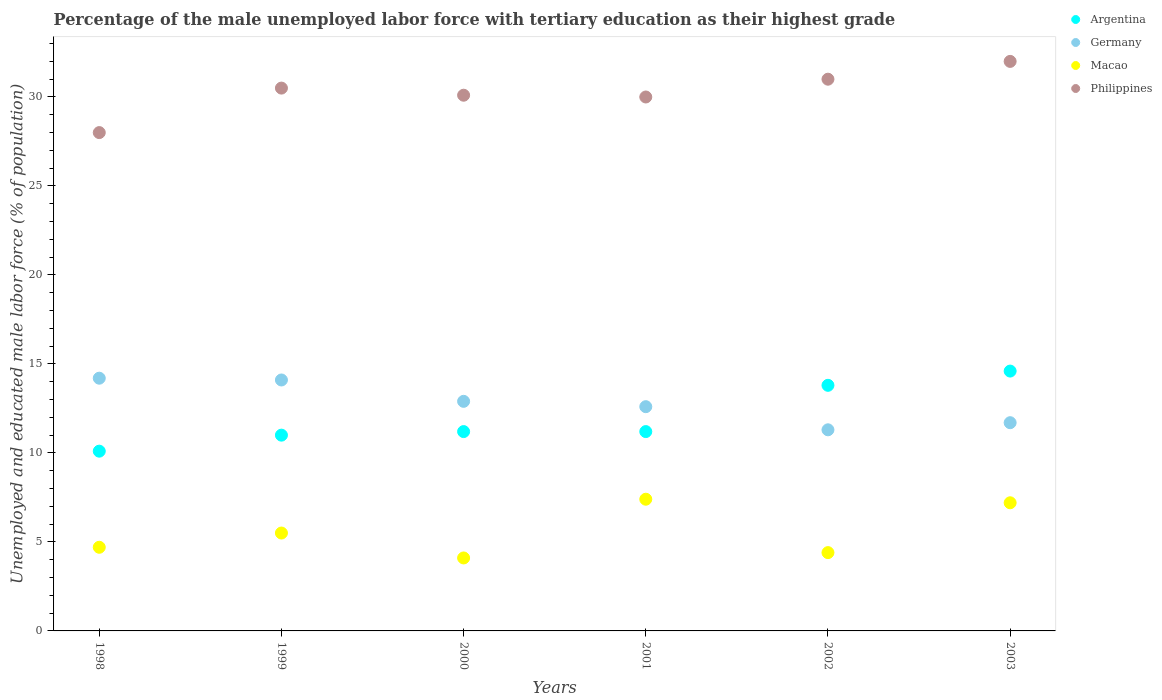How many different coloured dotlines are there?
Provide a succinct answer. 4. Is the number of dotlines equal to the number of legend labels?
Give a very brief answer. Yes. What is the percentage of the unemployed male labor force with tertiary education in Argentina in 2003?
Offer a terse response. 14.6. Across all years, what is the maximum percentage of the unemployed male labor force with tertiary education in Philippines?
Give a very brief answer. 32. Across all years, what is the minimum percentage of the unemployed male labor force with tertiary education in Germany?
Provide a short and direct response. 11.3. What is the total percentage of the unemployed male labor force with tertiary education in Argentina in the graph?
Offer a very short reply. 71.9. What is the difference between the percentage of the unemployed male labor force with tertiary education in Argentina in 2001 and that in 2003?
Your answer should be very brief. -3.4. What is the difference between the percentage of the unemployed male labor force with tertiary education in Macao in 2002 and the percentage of the unemployed male labor force with tertiary education in Argentina in 2000?
Provide a short and direct response. -6.8. What is the average percentage of the unemployed male labor force with tertiary education in Philippines per year?
Offer a terse response. 30.27. In the year 1998, what is the difference between the percentage of the unemployed male labor force with tertiary education in Philippines and percentage of the unemployed male labor force with tertiary education in Macao?
Your answer should be very brief. 23.3. What is the ratio of the percentage of the unemployed male labor force with tertiary education in Macao in 2000 to that in 2001?
Offer a very short reply. 0.55. What is the difference between the highest and the second highest percentage of the unemployed male labor force with tertiary education in Argentina?
Your response must be concise. 0.8. What is the difference between the highest and the lowest percentage of the unemployed male labor force with tertiary education in Philippines?
Provide a short and direct response. 4. Is it the case that in every year, the sum of the percentage of the unemployed male labor force with tertiary education in Macao and percentage of the unemployed male labor force with tertiary education in Germany  is greater than the percentage of the unemployed male labor force with tertiary education in Philippines?
Keep it short and to the point. No. Does the percentage of the unemployed male labor force with tertiary education in Argentina monotonically increase over the years?
Offer a very short reply. No. Where does the legend appear in the graph?
Your answer should be very brief. Top right. How many legend labels are there?
Your answer should be very brief. 4. How are the legend labels stacked?
Make the answer very short. Vertical. What is the title of the graph?
Ensure brevity in your answer.  Percentage of the male unemployed labor force with tertiary education as their highest grade. Does "Russian Federation" appear as one of the legend labels in the graph?
Provide a short and direct response. No. What is the label or title of the X-axis?
Ensure brevity in your answer.  Years. What is the label or title of the Y-axis?
Make the answer very short. Unemployed and educated male labor force (% of population). What is the Unemployed and educated male labor force (% of population) in Argentina in 1998?
Make the answer very short. 10.1. What is the Unemployed and educated male labor force (% of population) of Germany in 1998?
Keep it short and to the point. 14.2. What is the Unemployed and educated male labor force (% of population) in Macao in 1998?
Your answer should be compact. 4.7. What is the Unemployed and educated male labor force (% of population) of Argentina in 1999?
Your response must be concise. 11. What is the Unemployed and educated male labor force (% of population) of Germany in 1999?
Your response must be concise. 14.1. What is the Unemployed and educated male labor force (% of population) of Philippines in 1999?
Keep it short and to the point. 30.5. What is the Unemployed and educated male labor force (% of population) in Argentina in 2000?
Keep it short and to the point. 11.2. What is the Unemployed and educated male labor force (% of population) in Germany in 2000?
Make the answer very short. 12.9. What is the Unemployed and educated male labor force (% of population) in Macao in 2000?
Offer a terse response. 4.1. What is the Unemployed and educated male labor force (% of population) in Philippines in 2000?
Your answer should be compact. 30.1. What is the Unemployed and educated male labor force (% of population) of Argentina in 2001?
Provide a short and direct response. 11.2. What is the Unemployed and educated male labor force (% of population) of Germany in 2001?
Offer a terse response. 12.6. What is the Unemployed and educated male labor force (% of population) of Macao in 2001?
Your answer should be very brief. 7.4. What is the Unemployed and educated male labor force (% of population) of Philippines in 2001?
Your answer should be compact. 30. What is the Unemployed and educated male labor force (% of population) in Argentina in 2002?
Offer a terse response. 13.8. What is the Unemployed and educated male labor force (% of population) in Germany in 2002?
Provide a succinct answer. 11.3. What is the Unemployed and educated male labor force (% of population) in Macao in 2002?
Make the answer very short. 4.4. What is the Unemployed and educated male labor force (% of population) of Argentina in 2003?
Your response must be concise. 14.6. What is the Unemployed and educated male labor force (% of population) of Germany in 2003?
Offer a terse response. 11.7. What is the Unemployed and educated male labor force (% of population) of Macao in 2003?
Give a very brief answer. 7.2. What is the Unemployed and educated male labor force (% of population) in Philippines in 2003?
Provide a short and direct response. 32. Across all years, what is the maximum Unemployed and educated male labor force (% of population) in Argentina?
Offer a very short reply. 14.6. Across all years, what is the maximum Unemployed and educated male labor force (% of population) in Germany?
Ensure brevity in your answer.  14.2. Across all years, what is the maximum Unemployed and educated male labor force (% of population) of Macao?
Make the answer very short. 7.4. Across all years, what is the maximum Unemployed and educated male labor force (% of population) in Philippines?
Keep it short and to the point. 32. Across all years, what is the minimum Unemployed and educated male labor force (% of population) in Argentina?
Your response must be concise. 10.1. Across all years, what is the minimum Unemployed and educated male labor force (% of population) of Germany?
Make the answer very short. 11.3. Across all years, what is the minimum Unemployed and educated male labor force (% of population) in Macao?
Your response must be concise. 4.1. What is the total Unemployed and educated male labor force (% of population) in Argentina in the graph?
Your response must be concise. 71.9. What is the total Unemployed and educated male labor force (% of population) in Germany in the graph?
Your response must be concise. 76.8. What is the total Unemployed and educated male labor force (% of population) in Macao in the graph?
Keep it short and to the point. 33.3. What is the total Unemployed and educated male labor force (% of population) of Philippines in the graph?
Provide a short and direct response. 181.6. What is the difference between the Unemployed and educated male labor force (% of population) in Germany in 1998 and that in 1999?
Your response must be concise. 0.1. What is the difference between the Unemployed and educated male labor force (% of population) in Macao in 1998 and that in 1999?
Make the answer very short. -0.8. What is the difference between the Unemployed and educated male labor force (% of population) of Macao in 1998 and that in 2000?
Your answer should be compact. 0.6. What is the difference between the Unemployed and educated male labor force (% of population) of Argentina in 1998 and that in 2001?
Provide a succinct answer. -1.1. What is the difference between the Unemployed and educated male labor force (% of population) of Macao in 1998 and that in 2001?
Your answer should be very brief. -2.7. What is the difference between the Unemployed and educated male labor force (% of population) of Philippines in 1998 and that in 2002?
Your response must be concise. -3. What is the difference between the Unemployed and educated male labor force (% of population) in Argentina in 1998 and that in 2003?
Your answer should be very brief. -4.5. What is the difference between the Unemployed and educated male labor force (% of population) in Philippines in 1998 and that in 2003?
Provide a short and direct response. -4. What is the difference between the Unemployed and educated male labor force (% of population) of Philippines in 1999 and that in 2000?
Your response must be concise. 0.4. What is the difference between the Unemployed and educated male labor force (% of population) in Germany in 1999 and that in 2001?
Ensure brevity in your answer.  1.5. What is the difference between the Unemployed and educated male labor force (% of population) of Macao in 1999 and that in 2001?
Ensure brevity in your answer.  -1.9. What is the difference between the Unemployed and educated male labor force (% of population) of Philippines in 1999 and that in 2001?
Your response must be concise. 0.5. What is the difference between the Unemployed and educated male labor force (% of population) in Argentina in 1999 and that in 2002?
Provide a succinct answer. -2.8. What is the difference between the Unemployed and educated male labor force (% of population) in Macao in 1999 and that in 2002?
Give a very brief answer. 1.1. What is the difference between the Unemployed and educated male labor force (% of population) in Philippines in 1999 and that in 2002?
Your response must be concise. -0.5. What is the difference between the Unemployed and educated male labor force (% of population) of Germany in 1999 and that in 2003?
Keep it short and to the point. 2.4. What is the difference between the Unemployed and educated male labor force (% of population) in Macao in 2000 and that in 2001?
Provide a succinct answer. -3.3. What is the difference between the Unemployed and educated male labor force (% of population) of Germany in 2000 and that in 2002?
Your answer should be compact. 1.6. What is the difference between the Unemployed and educated male labor force (% of population) in Macao in 2000 and that in 2002?
Offer a very short reply. -0.3. What is the difference between the Unemployed and educated male labor force (% of population) of Germany in 2000 and that in 2003?
Give a very brief answer. 1.2. What is the difference between the Unemployed and educated male labor force (% of population) of Philippines in 2000 and that in 2003?
Make the answer very short. -1.9. What is the difference between the Unemployed and educated male labor force (% of population) of Macao in 2001 and that in 2002?
Offer a very short reply. 3. What is the difference between the Unemployed and educated male labor force (% of population) in Argentina in 2001 and that in 2003?
Make the answer very short. -3.4. What is the difference between the Unemployed and educated male labor force (% of population) of Germany in 2001 and that in 2003?
Your response must be concise. 0.9. What is the difference between the Unemployed and educated male labor force (% of population) in Macao in 2001 and that in 2003?
Your answer should be compact. 0.2. What is the difference between the Unemployed and educated male labor force (% of population) in Argentina in 2002 and that in 2003?
Make the answer very short. -0.8. What is the difference between the Unemployed and educated male labor force (% of population) of Germany in 2002 and that in 2003?
Offer a very short reply. -0.4. What is the difference between the Unemployed and educated male labor force (% of population) of Macao in 2002 and that in 2003?
Provide a succinct answer. -2.8. What is the difference between the Unemployed and educated male labor force (% of population) of Argentina in 1998 and the Unemployed and educated male labor force (% of population) of Philippines in 1999?
Ensure brevity in your answer.  -20.4. What is the difference between the Unemployed and educated male labor force (% of population) in Germany in 1998 and the Unemployed and educated male labor force (% of population) in Macao in 1999?
Give a very brief answer. 8.7. What is the difference between the Unemployed and educated male labor force (% of population) in Germany in 1998 and the Unemployed and educated male labor force (% of population) in Philippines in 1999?
Ensure brevity in your answer.  -16.3. What is the difference between the Unemployed and educated male labor force (% of population) of Macao in 1998 and the Unemployed and educated male labor force (% of population) of Philippines in 1999?
Your response must be concise. -25.8. What is the difference between the Unemployed and educated male labor force (% of population) of Argentina in 1998 and the Unemployed and educated male labor force (% of population) of Germany in 2000?
Your answer should be compact. -2.8. What is the difference between the Unemployed and educated male labor force (% of population) of Argentina in 1998 and the Unemployed and educated male labor force (% of population) of Macao in 2000?
Your response must be concise. 6. What is the difference between the Unemployed and educated male labor force (% of population) of Argentina in 1998 and the Unemployed and educated male labor force (% of population) of Philippines in 2000?
Provide a short and direct response. -20. What is the difference between the Unemployed and educated male labor force (% of population) in Germany in 1998 and the Unemployed and educated male labor force (% of population) in Philippines in 2000?
Provide a short and direct response. -15.9. What is the difference between the Unemployed and educated male labor force (% of population) in Macao in 1998 and the Unemployed and educated male labor force (% of population) in Philippines in 2000?
Your response must be concise. -25.4. What is the difference between the Unemployed and educated male labor force (% of population) of Argentina in 1998 and the Unemployed and educated male labor force (% of population) of Macao in 2001?
Provide a short and direct response. 2.7. What is the difference between the Unemployed and educated male labor force (% of population) of Argentina in 1998 and the Unemployed and educated male labor force (% of population) of Philippines in 2001?
Make the answer very short. -19.9. What is the difference between the Unemployed and educated male labor force (% of population) in Germany in 1998 and the Unemployed and educated male labor force (% of population) in Philippines in 2001?
Provide a short and direct response. -15.8. What is the difference between the Unemployed and educated male labor force (% of population) in Macao in 1998 and the Unemployed and educated male labor force (% of population) in Philippines in 2001?
Offer a very short reply. -25.3. What is the difference between the Unemployed and educated male labor force (% of population) in Argentina in 1998 and the Unemployed and educated male labor force (% of population) in Germany in 2002?
Keep it short and to the point. -1.2. What is the difference between the Unemployed and educated male labor force (% of population) in Argentina in 1998 and the Unemployed and educated male labor force (% of population) in Philippines in 2002?
Offer a terse response. -20.9. What is the difference between the Unemployed and educated male labor force (% of population) in Germany in 1998 and the Unemployed and educated male labor force (% of population) in Philippines in 2002?
Your answer should be compact. -16.8. What is the difference between the Unemployed and educated male labor force (% of population) of Macao in 1998 and the Unemployed and educated male labor force (% of population) of Philippines in 2002?
Keep it short and to the point. -26.3. What is the difference between the Unemployed and educated male labor force (% of population) of Argentina in 1998 and the Unemployed and educated male labor force (% of population) of Germany in 2003?
Offer a very short reply. -1.6. What is the difference between the Unemployed and educated male labor force (% of population) of Argentina in 1998 and the Unemployed and educated male labor force (% of population) of Macao in 2003?
Provide a succinct answer. 2.9. What is the difference between the Unemployed and educated male labor force (% of population) of Argentina in 1998 and the Unemployed and educated male labor force (% of population) of Philippines in 2003?
Your response must be concise. -21.9. What is the difference between the Unemployed and educated male labor force (% of population) in Germany in 1998 and the Unemployed and educated male labor force (% of population) in Macao in 2003?
Provide a short and direct response. 7. What is the difference between the Unemployed and educated male labor force (% of population) in Germany in 1998 and the Unemployed and educated male labor force (% of population) in Philippines in 2003?
Your answer should be very brief. -17.8. What is the difference between the Unemployed and educated male labor force (% of population) in Macao in 1998 and the Unemployed and educated male labor force (% of population) in Philippines in 2003?
Make the answer very short. -27.3. What is the difference between the Unemployed and educated male labor force (% of population) of Argentina in 1999 and the Unemployed and educated male labor force (% of population) of Germany in 2000?
Your response must be concise. -1.9. What is the difference between the Unemployed and educated male labor force (% of population) of Argentina in 1999 and the Unemployed and educated male labor force (% of population) of Macao in 2000?
Make the answer very short. 6.9. What is the difference between the Unemployed and educated male labor force (% of population) in Argentina in 1999 and the Unemployed and educated male labor force (% of population) in Philippines in 2000?
Offer a very short reply. -19.1. What is the difference between the Unemployed and educated male labor force (% of population) of Germany in 1999 and the Unemployed and educated male labor force (% of population) of Macao in 2000?
Your response must be concise. 10. What is the difference between the Unemployed and educated male labor force (% of population) in Germany in 1999 and the Unemployed and educated male labor force (% of population) in Philippines in 2000?
Your answer should be compact. -16. What is the difference between the Unemployed and educated male labor force (% of population) in Macao in 1999 and the Unemployed and educated male labor force (% of population) in Philippines in 2000?
Keep it short and to the point. -24.6. What is the difference between the Unemployed and educated male labor force (% of population) of Argentina in 1999 and the Unemployed and educated male labor force (% of population) of Philippines in 2001?
Provide a short and direct response. -19. What is the difference between the Unemployed and educated male labor force (% of population) in Germany in 1999 and the Unemployed and educated male labor force (% of population) in Philippines in 2001?
Provide a short and direct response. -15.9. What is the difference between the Unemployed and educated male labor force (% of population) of Macao in 1999 and the Unemployed and educated male labor force (% of population) of Philippines in 2001?
Keep it short and to the point. -24.5. What is the difference between the Unemployed and educated male labor force (% of population) in Argentina in 1999 and the Unemployed and educated male labor force (% of population) in Macao in 2002?
Your answer should be very brief. 6.6. What is the difference between the Unemployed and educated male labor force (% of population) in Argentina in 1999 and the Unemployed and educated male labor force (% of population) in Philippines in 2002?
Offer a very short reply. -20. What is the difference between the Unemployed and educated male labor force (% of population) in Germany in 1999 and the Unemployed and educated male labor force (% of population) in Macao in 2002?
Give a very brief answer. 9.7. What is the difference between the Unemployed and educated male labor force (% of population) of Germany in 1999 and the Unemployed and educated male labor force (% of population) of Philippines in 2002?
Your answer should be very brief. -16.9. What is the difference between the Unemployed and educated male labor force (% of population) in Macao in 1999 and the Unemployed and educated male labor force (% of population) in Philippines in 2002?
Keep it short and to the point. -25.5. What is the difference between the Unemployed and educated male labor force (% of population) in Argentina in 1999 and the Unemployed and educated male labor force (% of population) in Germany in 2003?
Your answer should be compact. -0.7. What is the difference between the Unemployed and educated male labor force (% of population) of Argentina in 1999 and the Unemployed and educated male labor force (% of population) of Macao in 2003?
Your answer should be very brief. 3.8. What is the difference between the Unemployed and educated male labor force (% of population) in Argentina in 1999 and the Unemployed and educated male labor force (% of population) in Philippines in 2003?
Keep it short and to the point. -21. What is the difference between the Unemployed and educated male labor force (% of population) of Germany in 1999 and the Unemployed and educated male labor force (% of population) of Philippines in 2003?
Give a very brief answer. -17.9. What is the difference between the Unemployed and educated male labor force (% of population) of Macao in 1999 and the Unemployed and educated male labor force (% of population) of Philippines in 2003?
Offer a terse response. -26.5. What is the difference between the Unemployed and educated male labor force (% of population) in Argentina in 2000 and the Unemployed and educated male labor force (% of population) in Germany in 2001?
Offer a very short reply. -1.4. What is the difference between the Unemployed and educated male labor force (% of population) of Argentina in 2000 and the Unemployed and educated male labor force (% of population) of Macao in 2001?
Offer a terse response. 3.8. What is the difference between the Unemployed and educated male labor force (% of population) of Argentina in 2000 and the Unemployed and educated male labor force (% of population) of Philippines in 2001?
Make the answer very short. -18.8. What is the difference between the Unemployed and educated male labor force (% of population) of Germany in 2000 and the Unemployed and educated male labor force (% of population) of Philippines in 2001?
Your answer should be very brief. -17.1. What is the difference between the Unemployed and educated male labor force (% of population) of Macao in 2000 and the Unemployed and educated male labor force (% of population) of Philippines in 2001?
Keep it short and to the point. -25.9. What is the difference between the Unemployed and educated male labor force (% of population) in Argentina in 2000 and the Unemployed and educated male labor force (% of population) in Germany in 2002?
Offer a terse response. -0.1. What is the difference between the Unemployed and educated male labor force (% of population) of Argentina in 2000 and the Unemployed and educated male labor force (% of population) of Macao in 2002?
Your answer should be very brief. 6.8. What is the difference between the Unemployed and educated male labor force (% of population) in Argentina in 2000 and the Unemployed and educated male labor force (% of population) in Philippines in 2002?
Keep it short and to the point. -19.8. What is the difference between the Unemployed and educated male labor force (% of population) of Germany in 2000 and the Unemployed and educated male labor force (% of population) of Macao in 2002?
Keep it short and to the point. 8.5. What is the difference between the Unemployed and educated male labor force (% of population) of Germany in 2000 and the Unemployed and educated male labor force (% of population) of Philippines in 2002?
Your response must be concise. -18.1. What is the difference between the Unemployed and educated male labor force (% of population) in Macao in 2000 and the Unemployed and educated male labor force (% of population) in Philippines in 2002?
Provide a succinct answer. -26.9. What is the difference between the Unemployed and educated male labor force (% of population) in Argentina in 2000 and the Unemployed and educated male labor force (% of population) in Philippines in 2003?
Keep it short and to the point. -20.8. What is the difference between the Unemployed and educated male labor force (% of population) of Germany in 2000 and the Unemployed and educated male labor force (% of population) of Philippines in 2003?
Your answer should be compact. -19.1. What is the difference between the Unemployed and educated male labor force (% of population) in Macao in 2000 and the Unemployed and educated male labor force (% of population) in Philippines in 2003?
Offer a very short reply. -27.9. What is the difference between the Unemployed and educated male labor force (% of population) in Argentina in 2001 and the Unemployed and educated male labor force (% of population) in Germany in 2002?
Provide a short and direct response. -0.1. What is the difference between the Unemployed and educated male labor force (% of population) of Argentina in 2001 and the Unemployed and educated male labor force (% of population) of Macao in 2002?
Offer a very short reply. 6.8. What is the difference between the Unemployed and educated male labor force (% of population) of Argentina in 2001 and the Unemployed and educated male labor force (% of population) of Philippines in 2002?
Your response must be concise. -19.8. What is the difference between the Unemployed and educated male labor force (% of population) of Germany in 2001 and the Unemployed and educated male labor force (% of population) of Macao in 2002?
Give a very brief answer. 8.2. What is the difference between the Unemployed and educated male labor force (% of population) of Germany in 2001 and the Unemployed and educated male labor force (% of population) of Philippines in 2002?
Your answer should be compact. -18.4. What is the difference between the Unemployed and educated male labor force (% of population) in Macao in 2001 and the Unemployed and educated male labor force (% of population) in Philippines in 2002?
Provide a succinct answer. -23.6. What is the difference between the Unemployed and educated male labor force (% of population) in Argentina in 2001 and the Unemployed and educated male labor force (% of population) in Macao in 2003?
Ensure brevity in your answer.  4. What is the difference between the Unemployed and educated male labor force (% of population) of Argentina in 2001 and the Unemployed and educated male labor force (% of population) of Philippines in 2003?
Your answer should be compact. -20.8. What is the difference between the Unemployed and educated male labor force (% of population) of Germany in 2001 and the Unemployed and educated male labor force (% of population) of Philippines in 2003?
Your answer should be very brief. -19.4. What is the difference between the Unemployed and educated male labor force (% of population) of Macao in 2001 and the Unemployed and educated male labor force (% of population) of Philippines in 2003?
Your response must be concise. -24.6. What is the difference between the Unemployed and educated male labor force (% of population) of Argentina in 2002 and the Unemployed and educated male labor force (% of population) of Germany in 2003?
Provide a short and direct response. 2.1. What is the difference between the Unemployed and educated male labor force (% of population) of Argentina in 2002 and the Unemployed and educated male labor force (% of population) of Macao in 2003?
Offer a terse response. 6.6. What is the difference between the Unemployed and educated male labor force (% of population) of Argentina in 2002 and the Unemployed and educated male labor force (% of population) of Philippines in 2003?
Keep it short and to the point. -18.2. What is the difference between the Unemployed and educated male labor force (% of population) of Germany in 2002 and the Unemployed and educated male labor force (% of population) of Philippines in 2003?
Make the answer very short. -20.7. What is the difference between the Unemployed and educated male labor force (% of population) of Macao in 2002 and the Unemployed and educated male labor force (% of population) of Philippines in 2003?
Make the answer very short. -27.6. What is the average Unemployed and educated male labor force (% of population) of Argentina per year?
Give a very brief answer. 11.98. What is the average Unemployed and educated male labor force (% of population) in Germany per year?
Your answer should be very brief. 12.8. What is the average Unemployed and educated male labor force (% of population) of Macao per year?
Keep it short and to the point. 5.55. What is the average Unemployed and educated male labor force (% of population) of Philippines per year?
Your answer should be compact. 30.27. In the year 1998, what is the difference between the Unemployed and educated male labor force (% of population) of Argentina and Unemployed and educated male labor force (% of population) of Germany?
Keep it short and to the point. -4.1. In the year 1998, what is the difference between the Unemployed and educated male labor force (% of population) in Argentina and Unemployed and educated male labor force (% of population) in Macao?
Offer a very short reply. 5.4. In the year 1998, what is the difference between the Unemployed and educated male labor force (% of population) in Argentina and Unemployed and educated male labor force (% of population) in Philippines?
Offer a very short reply. -17.9. In the year 1998, what is the difference between the Unemployed and educated male labor force (% of population) of Macao and Unemployed and educated male labor force (% of population) of Philippines?
Provide a succinct answer. -23.3. In the year 1999, what is the difference between the Unemployed and educated male labor force (% of population) in Argentina and Unemployed and educated male labor force (% of population) in Philippines?
Your answer should be very brief. -19.5. In the year 1999, what is the difference between the Unemployed and educated male labor force (% of population) in Germany and Unemployed and educated male labor force (% of population) in Macao?
Provide a short and direct response. 8.6. In the year 1999, what is the difference between the Unemployed and educated male labor force (% of population) in Germany and Unemployed and educated male labor force (% of population) in Philippines?
Offer a terse response. -16.4. In the year 1999, what is the difference between the Unemployed and educated male labor force (% of population) in Macao and Unemployed and educated male labor force (% of population) in Philippines?
Your response must be concise. -25. In the year 2000, what is the difference between the Unemployed and educated male labor force (% of population) in Argentina and Unemployed and educated male labor force (% of population) in Germany?
Your answer should be compact. -1.7. In the year 2000, what is the difference between the Unemployed and educated male labor force (% of population) of Argentina and Unemployed and educated male labor force (% of population) of Macao?
Your answer should be very brief. 7.1. In the year 2000, what is the difference between the Unemployed and educated male labor force (% of population) of Argentina and Unemployed and educated male labor force (% of population) of Philippines?
Keep it short and to the point. -18.9. In the year 2000, what is the difference between the Unemployed and educated male labor force (% of population) of Germany and Unemployed and educated male labor force (% of population) of Macao?
Provide a succinct answer. 8.8. In the year 2000, what is the difference between the Unemployed and educated male labor force (% of population) in Germany and Unemployed and educated male labor force (% of population) in Philippines?
Give a very brief answer. -17.2. In the year 2001, what is the difference between the Unemployed and educated male labor force (% of population) of Argentina and Unemployed and educated male labor force (% of population) of Philippines?
Your response must be concise. -18.8. In the year 2001, what is the difference between the Unemployed and educated male labor force (% of population) in Germany and Unemployed and educated male labor force (% of population) in Philippines?
Give a very brief answer. -17.4. In the year 2001, what is the difference between the Unemployed and educated male labor force (% of population) in Macao and Unemployed and educated male labor force (% of population) in Philippines?
Provide a short and direct response. -22.6. In the year 2002, what is the difference between the Unemployed and educated male labor force (% of population) of Argentina and Unemployed and educated male labor force (% of population) of Philippines?
Make the answer very short. -17.2. In the year 2002, what is the difference between the Unemployed and educated male labor force (% of population) in Germany and Unemployed and educated male labor force (% of population) in Philippines?
Provide a short and direct response. -19.7. In the year 2002, what is the difference between the Unemployed and educated male labor force (% of population) in Macao and Unemployed and educated male labor force (% of population) in Philippines?
Your response must be concise. -26.6. In the year 2003, what is the difference between the Unemployed and educated male labor force (% of population) in Argentina and Unemployed and educated male labor force (% of population) in Germany?
Your answer should be compact. 2.9. In the year 2003, what is the difference between the Unemployed and educated male labor force (% of population) of Argentina and Unemployed and educated male labor force (% of population) of Philippines?
Your answer should be very brief. -17.4. In the year 2003, what is the difference between the Unemployed and educated male labor force (% of population) in Germany and Unemployed and educated male labor force (% of population) in Macao?
Your answer should be very brief. 4.5. In the year 2003, what is the difference between the Unemployed and educated male labor force (% of population) in Germany and Unemployed and educated male labor force (% of population) in Philippines?
Ensure brevity in your answer.  -20.3. In the year 2003, what is the difference between the Unemployed and educated male labor force (% of population) in Macao and Unemployed and educated male labor force (% of population) in Philippines?
Keep it short and to the point. -24.8. What is the ratio of the Unemployed and educated male labor force (% of population) of Argentina in 1998 to that in 1999?
Offer a very short reply. 0.92. What is the ratio of the Unemployed and educated male labor force (% of population) of Germany in 1998 to that in 1999?
Your answer should be compact. 1.01. What is the ratio of the Unemployed and educated male labor force (% of population) in Macao in 1998 to that in 1999?
Your response must be concise. 0.85. What is the ratio of the Unemployed and educated male labor force (% of population) in Philippines in 1998 to that in 1999?
Provide a succinct answer. 0.92. What is the ratio of the Unemployed and educated male labor force (% of population) in Argentina in 1998 to that in 2000?
Give a very brief answer. 0.9. What is the ratio of the Unemployed and educated male labor force (% of population) of Germany in 1998 to that in 2000?
Offer a very short reply. 1.1. What is the ratio of the Unemployed and educated male labor force (% of population) of Macao in 1998 to that in 2000?
Your answer should be very brief. 1.15. What is the ratio of the Unemployed and educated male labor force (% of population) of Philippines in 1998 to that in 2000?
Provide a short and direct response. 0.93. What is the ratio of the Unemployed and educated male labor force (% of population) of Argentina in 1998 to that in 2001?
Your answer should be very brief. 0.9. What is the ratio of the Unemployed and educated male labor force (% of population) of Germany in 1998 to that in 2001?
Keep it short and to the point. 1.13. What is the ratio of the Unemployed and educated male labor force (% of population) of Macao in 1998 to that in 2001?
Offer a very short reply. 0.64. What is the ratio of the Unemployed and educated male labor force (% of population) in Argentina in 1998 to that in 2002?
Ensure brevity in your answer.  0.73. What is the ratio of the Unemployed and educated male labor force (% of population) of Germany in 1998 to that in 2002?
Offer a very short reply. 1.26. What is the ratio of the Unemployed and educated male labor force (% of population) in Macao in 1998 to that in 2002?
Your response must be concise. 1.07. What is the ratio of the Unemployed and educated male labor force (% of population) of Philippines in 1998 to that in 2002?
Ensure brevity in your answer.  0.9. What is the ratio of the Unemployed and educated male labor force (% of population) in Argentina in 1998 to that in 2003?
Keep it short and to the point. 0.69. What is the ratio of the Unemployed and educated male labor force (% of population) in Germany in 1998 to that in 2003?
Offer a terse response. 1.21. What is the ratio of the Unemployed and educated male labor force (% of population) of Macao in 1998 to that in 2003?
Offer a very short reply. 0.65. What is the ratio of the Unemployed and educated male labor force (% of population) of Philippines in 1998 to that in 2003?
Your response must be concise. 0.88. What is the ratio of the Unemployed and educated male labor force (% of population) in Argentina in 1999 to that in 2000?
Your response must be concise. 0.98. What is the ratio of the Unemployed and educated male labor force (% of population) in Germany in 1999 to that in 2000?
Provide a short and direct response. 1.09. What is the ratio of the Unemployed and educated male labor force (% of population) of Macao in 1999 to that in 2000?
Provide a short and direct response. 1.34. What is the ratio of the Unemployed and educated male labor force (% of population) of Philippines in 1999 to that in 2000?
Give a very brief answer. 1.01. What is the ratio of the Unemployed and educated male labor force (% of population) of Argentina in 1999 to that in 2001?
Your answer should be very brief. 0.98. What is the ratio of the Unemployed and educated male labor force (% of population) of Germany in 1999 to that in 2001?
Provide a short and direct response. 1.12. What is the ratio of the Unemployed and educated male labor force (% of population) of Macao in 1999 to that in 2001?
Provide a succinct answer. 0.74. What is the ratio of the Unemployed and educated male labor force (% of population) in Philippines in 1999 to that in 2001?
Your response must be concise. 1.02. What is the ratio of the Unemployed and educated male labor force (% of population) of Argentina in 1999 to that in 2002?
Provide a succinct answer. 0.8. What is the ratio of the Unemployed and educated male labor force (% of population) in Germany in 1999 to that in 2002?
Your answer should be very brief. 1.25. What is the ratio of the Unemployed and educated male labor force (% of population) in Philippines in 1999 to that in 2002?
Give a very brief answer. 0.98. What is the ratio of the Unemployed and educated male labor force (% of population) in Argentina in 1999 to that in 2003?
Ensure brevity in your answer.  0.75. What is the ratio of the Unemployed and educated male labor force (% of population) of Germany in 1999 to that in 2003?
Your answer should be very brief. 1.21. What is the ratio of the Unemployed and educated male labor force (% of population) of Macao in 1999 to that in 2003?
Make the answer very short. 0.76. What is the ratio of the Unemployed and educated male labor force (% of population) of Philippines in 1999 to that in 2003?
Offer a very short reply. 0.95. What is the ratio of the Unemployed and educated male labor force (% of population) in Germany in 2000 to that in 2001?
Keep it short and to the point. 1.02. What is the ratio of the Unemployed and educated male labor force (% of population) of Macao in 2000 to that in 2001?
Your response must be concise. 0.55. What is the ratio of the Unemployed and educated male labor force (% of population) in Argentina in 2000 to that in 2002?
Give a very brief answer. 0.81. What is the ratio of the Unemployed and educated male labor force (% of population) in Germany in 2000 to that in 2002?
Your response must be concise. 1.14. What is the ratio of the Unemployed and educated male labor force (% of population) of Macao in 2000 to that in 2002?
Your response must be concise. 0.93. What is the ratio of the Unemployed and educated male labor force (% of population) in Philippines in 2000 to that in 2002?
Your answer should be compact. 0.97. What is the ratio of the Unemployed and educated male labor force (% of population) in Argentina in 2000 to that in 2003?
Keep it short and to the point. 0.77. What is the ratio of the Unemployed and educated male labor force (% of population) of Germany in 2000 to that in 2003?
Keep it short and to the point. 1.1. What is the ratio of the Unemployed and educated male labor force (% of population) of Macao in 2000 to that in 2003?
Offer a very short reply. 0.57. What is the ratio of the Unemployed and educated male labor force (% of population) of Philippines in 2000 to that in 2003?
Offer a terse response. 0.94. What is the ratio of the Unemployed and educated male labor force (% of population) of Argentina in 2001 to that in 2002?
Your response must be concise. 0.81. What is the ratio of the Unemployed and educated male labor force (% of population) of Germany in 2001 to that in 2002?
Your response must be concise. 1.11. What is the ratio of the Unemployed and educated male labor force (% of population) in Macao in 2001 to that in 2002?
Your answer should be compact. 1.68. What is the ratio of the Unemployed and educated male labor force (% of population) of Philippines in 2001 to that in 2002?
Make the answer very short. 0.97. What is the ratio of the Unemployed and educated male labor force (% of population) in Argentina in 2001 to that in 2003?
Provide a short and direct response. 0.77. What is the ratio of the Unemployed and educated male labor force (% of population) of Macao in 2001 to that in 2003?
Offer a terse response. 1.03. What is the ratio of the Unemployed and educated male labor force (% of population) of Argentina in 2002 to that in 2003?
Your answer should be compact. 0.95. What is the ratio of the Unemployed and educated male labor force (% of population) of Germany in 2002 to that in 2003?
Make the answer very short. 0.97. What is the ratio of the Unemployed and educated male labor force (% of population) in Macao in 2002 to that in 2003?
Provide a succinct answer. 0.61. What is the ratio of the Unemployed and educated male labor force (% of population) of Philippines in 2002 to that in 2003?
Your answer should be compact. 0.97. What is the difference between the highest and the second highest Unemployed and educated male labor force (% of population) of Argentina?
Ensure brevity in your answer.  0.8. What is the difference between the highest and the second highest Unemployed and educated male labor force (% of population) in Germany?
Make the answer very short. 0.1. What is the difference between the highest and the second highest Unemployed and educated male labor force (% of population) in Philippines?
Your answer should be compact. 1. What is the difference between the highest and the lowest Unemployed and educated male labor force (% of population) of Germany?
Give a very brief answer. 2.9. What is the difference between the highest and the lowest Unemployed and educated male labor force (% of population) of Macao?
Give a very brief answer. 3.3. 